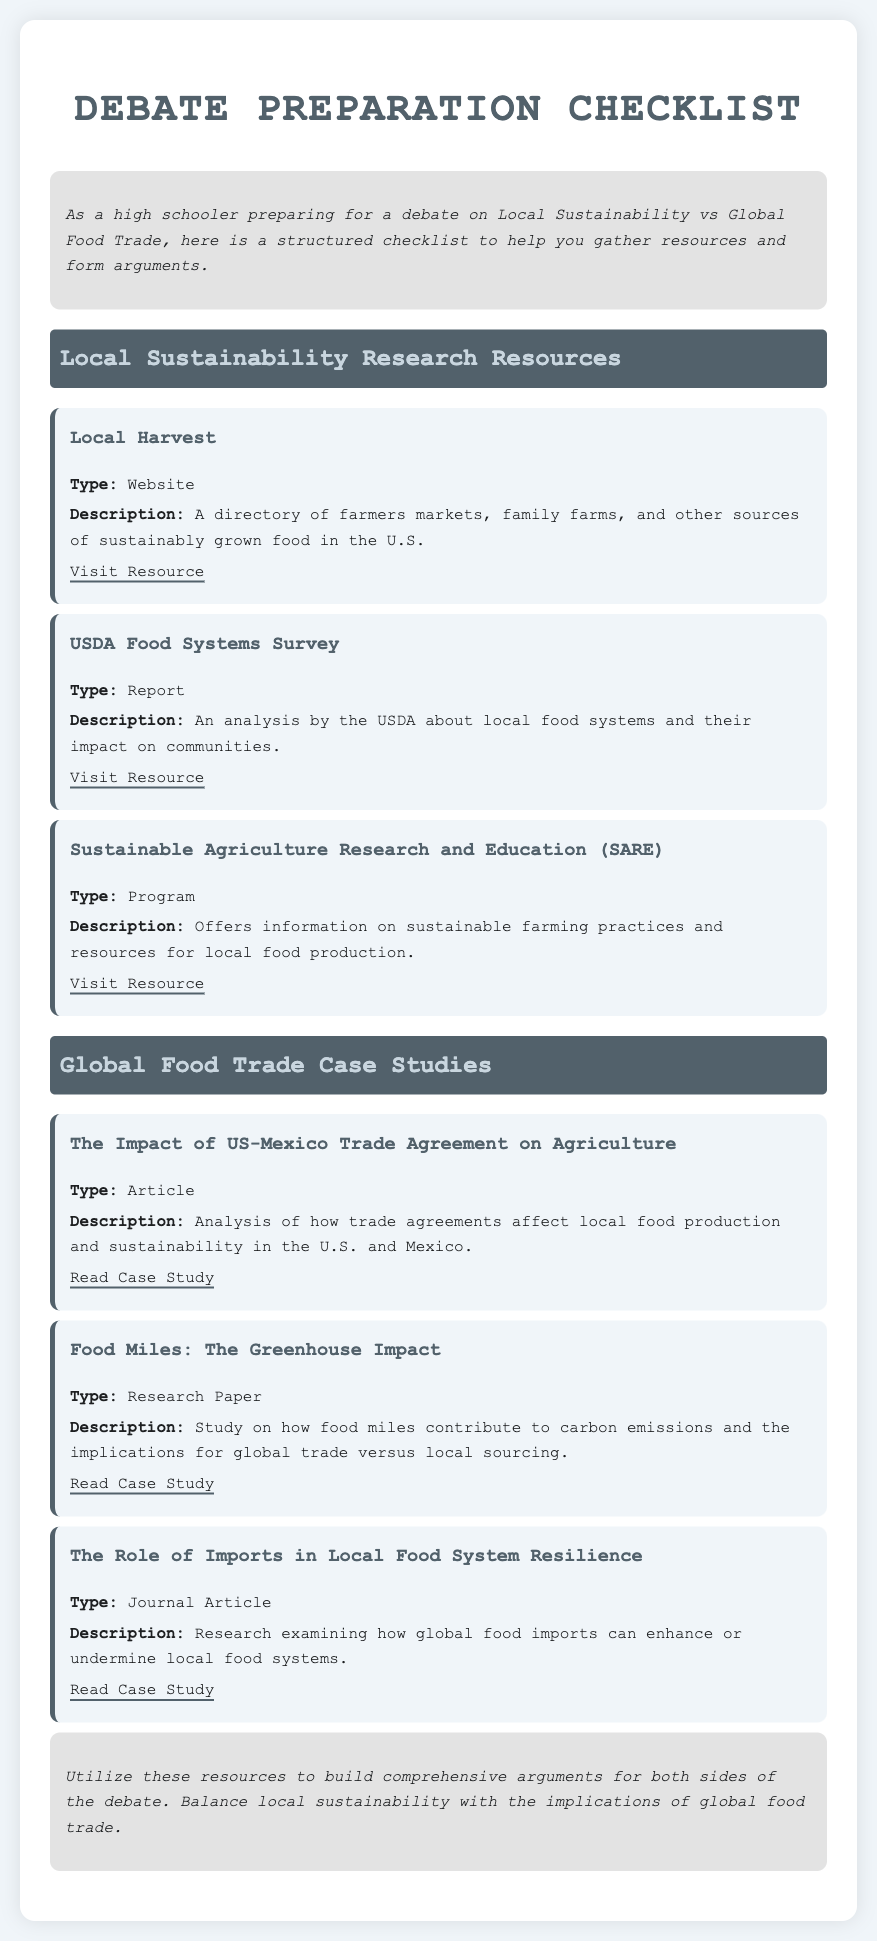what is the title of the document? The title of the document is the main heading displayed at the top of the page.
Answer: Debate Preparation Checklist how many local sustainability research resources are listed? The document lists the number of resources under the Local Sustainability Research Resources section.
Answer: 3 what is the type of the "USDA Food Systems Survey"? The type of the "USDA Food Systems Survey" is specified in the document.
Answer: Report what is the description of "Local Harvest"? The description given in the document elaborates on the purpose of "Local Harvest."
Answer: A directory of farmers markets, family farms, and other sources of sustainably grown food in the U.S which case study discusses the impact of food miles? The title of the case study relevant to food miles is provided in the document.
Answer: Food Miles: The Greenhouse Impact what does the conclusion suggest about resource utilization? The conclusion reflects on how to approach the resources listed.
Answer: Build comprehensive arguments for both sides of the debate who is the target audience of the document? The intended audience of the document is mentioned in the introductory paragraph.
Answer: High schoolers what is the name of the program that offers sustainable farming information? The document specifies the name of the relevant program in the resources section.
Answer: Sustainable Agriculture Research and Education (SARE) 